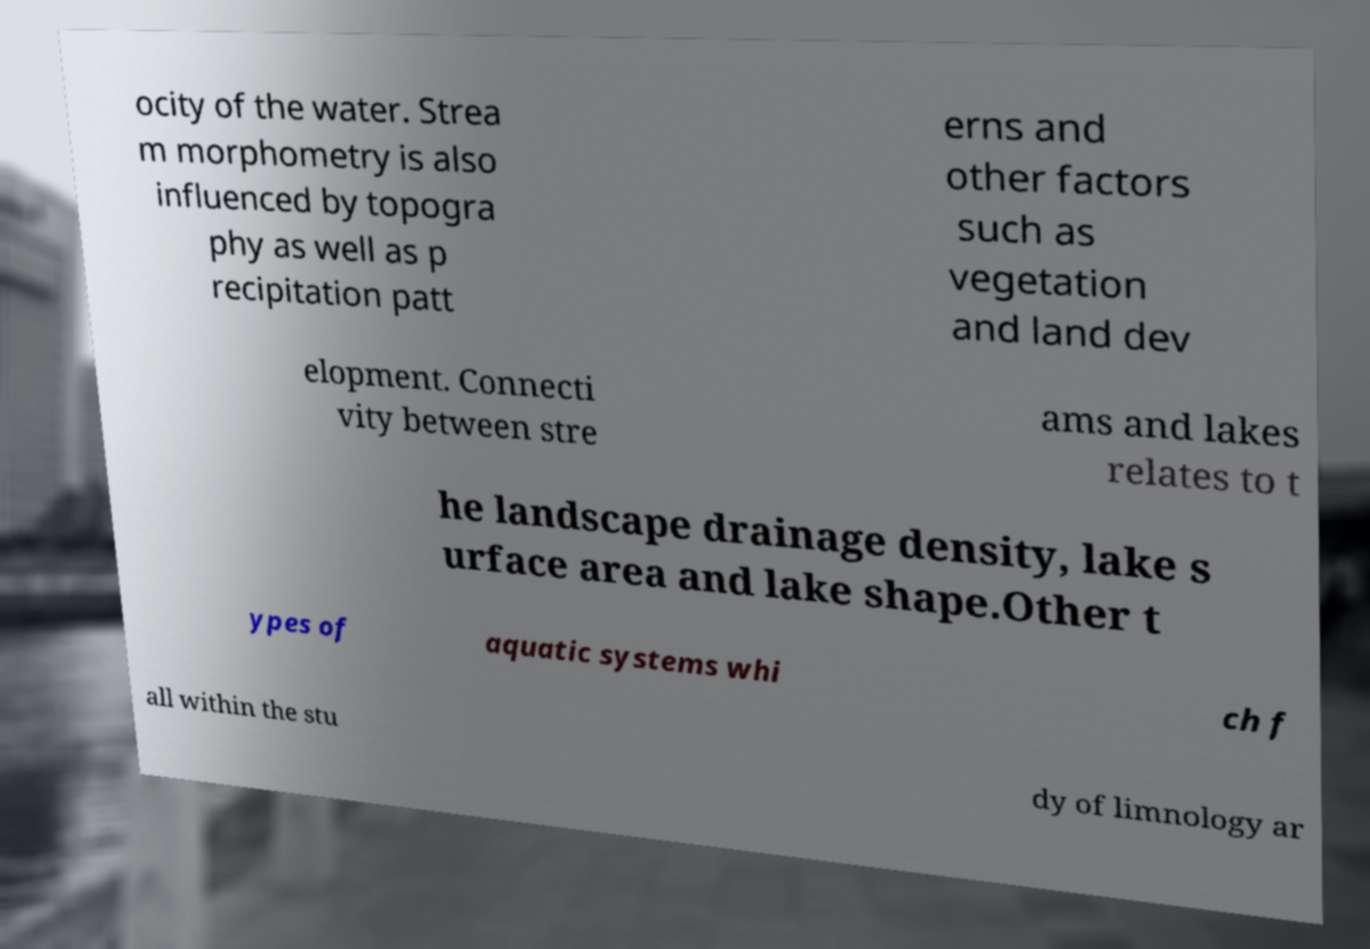Please read and relay the text visible in this image. What does it say? ocity of the water. Strea m morphometry is also influenced by topogra phy as well as p recipitation patt erns and other factors such as vegetation and land dev elopment. Connecti vity between stre ams and lakes relates to t he landscape drainage density, lake s urface area and lake shape.Other t ypes of aquatic systems whi ch f all within the stu dy of limnology ar 